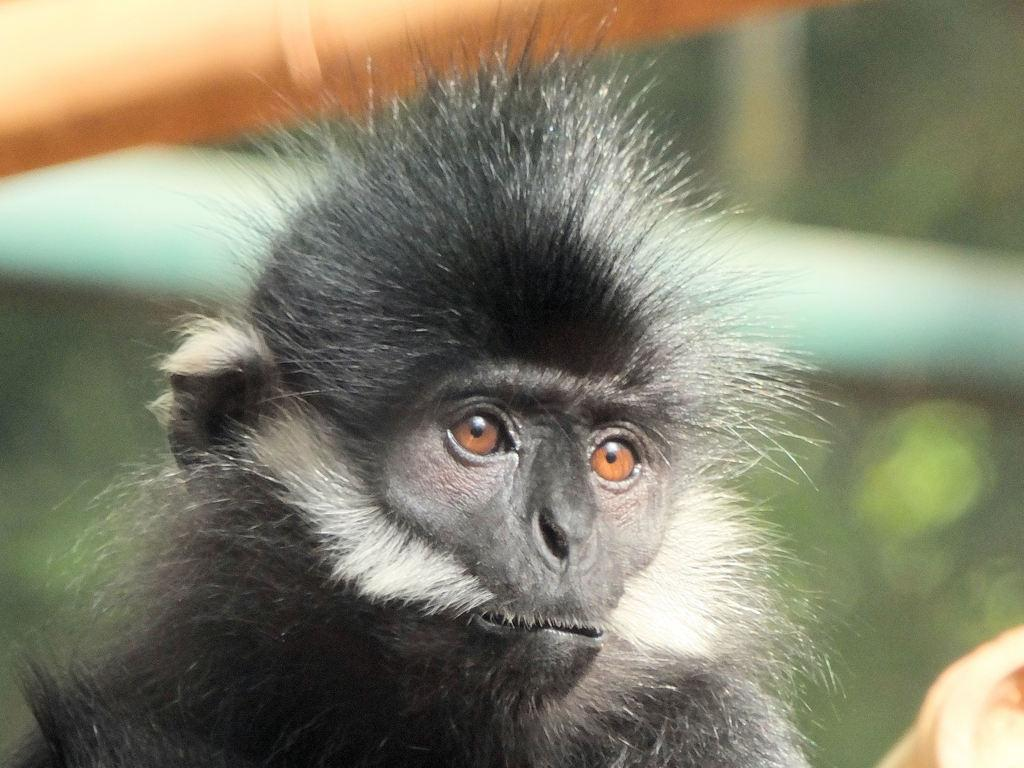What type of animal is in the image? There is a monkey in the image. What colors can be seen on the monkey? The monkey is white, gray, and black in color. Can you describe the background of the image? The background of the image is blurred. What type of beast can be seen sitting on the sofa in the image? There is no beast or sofa present in the image; it features a monkey. What hobbies does the monkey have, as depicted in the image? The image does not provide information about the monkey's hobbies. 